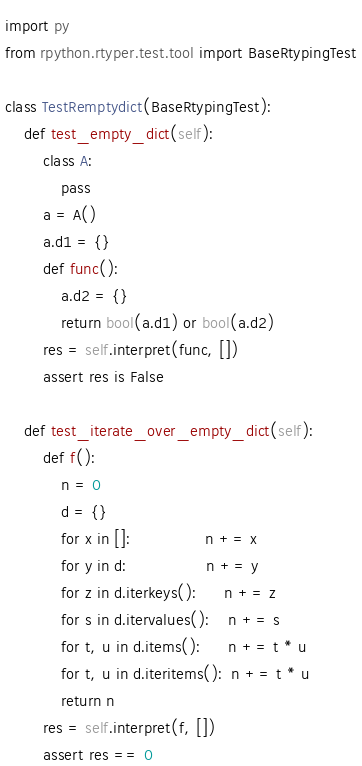<code> <loc_0><loc_0><loc_500><loc_500><_Python_>import py
from rpython.rtyper.test.tool import BaseRtypingTest

class TestRemptydict(BaseRtypingTest):
    def test_empty_dict(self):
        class A:
            pass
        a = A()
        a.d1 = {}
        def func():
            a.d2 = {}
            return bool(a.d1) or bool(a.d2)
        res = self.interpret(func, [])
        assert res is False

    def test_iterate_over_empty_dict(self):
        def f():
            n = 0
            d = {}
            for x in []:                n += x
            for y in d:                 n += y
            for z in d.iterkeys():      n += z
            for s in d.itervalues():    n += s
            for t, u in d.items():      n += t * u
            for t, u in d.iteritems():  n += t * u
            return n
        res = self.interpret(f, [])
        assert res == 0
</code> 